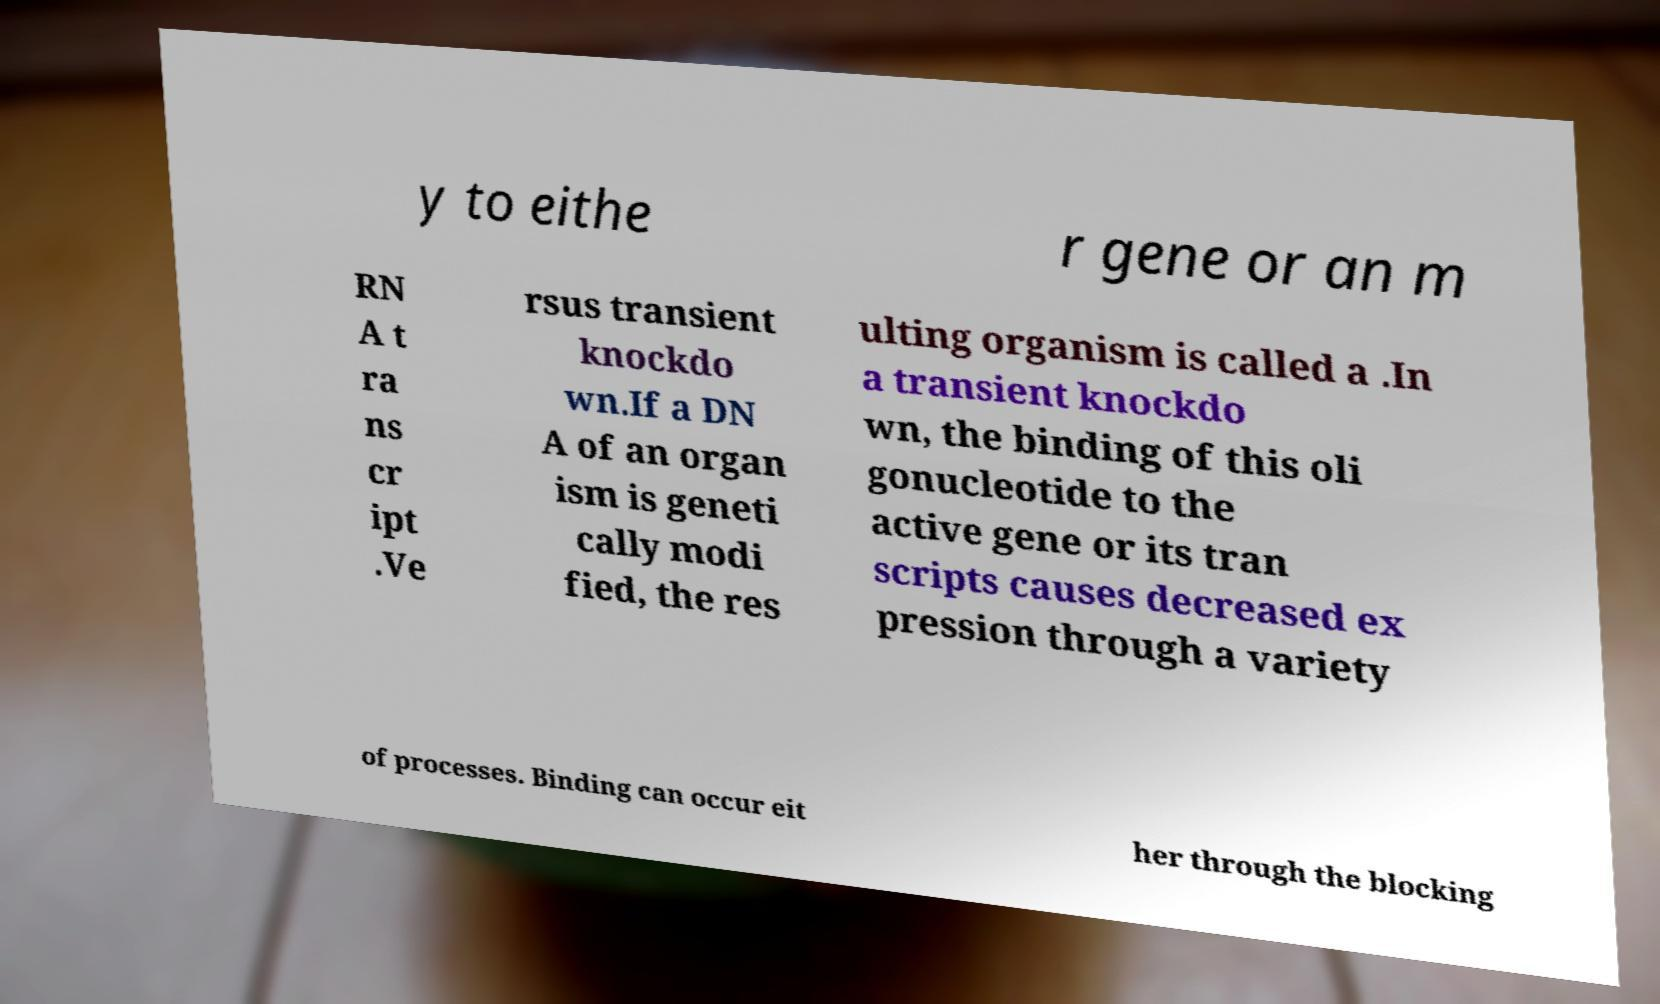Can you read and provide the text displayed in the image?This photo seems to have some interesting text. Can you extract and type it out for me? y to eithe r gene or an m RN A t ra ns cr ipt .Ve rsus transient knockdo wn.If a DN A of an organ ism is geneti cally modi fied, the res ulting organism is called a .In a transient knockdo wn, the binding of this oli gonucleotide to the active gene or its tran scripts causes decreased ex pression through a variety of processes. Binding can occur eit her through the blocking 